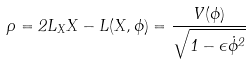Convert formula to latex. <formula><loc_0><loc_0><loc_500><loc_500>\rho = 2 L _ { X } X - L ( X , \phi ) = \frac { V ( \phi ) } { \sqrt { 1 - \epsilon \dot { \phi } ^ { 2 } } }</formula> 